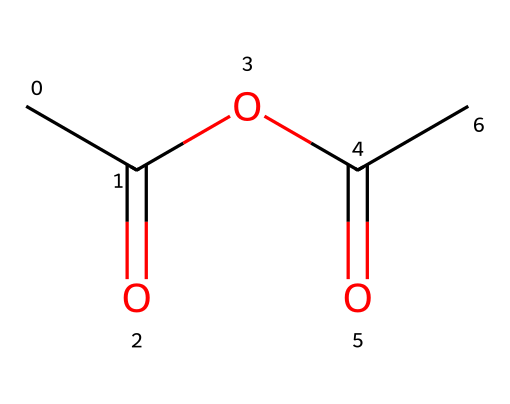How many carbon atoms are present in acetic anhydride? The SMILES representation CC(=O)OC(=O)C shows three distinct 'C' characters representing carbon atoms, hence there are three carbon atoms in acetic anhydride.
Answer: three What type of functional groups are present in this chemical structure? The acetic anhydride structure contains two carbonyl (C=O) groups and one ether (C-O) linkage, making them the primary functional groups present in the molecule.
Answer: carbonyl and ether What is the overall molecular formula of acetic anhydride? By counting the elements indicated in the SMILES, there are four hydrogen (H), six carbon (C), and two oxygen (O) atoms, leading to the molecular formula C4H6O3.
Answer: C4H6O3 Which atom is the central atom in the acetic anhydride structure? In acetic anhydride, the central focus is on the carbon atoms, as they form the backbone of the structure while linking to other functional groups, specifically the carbonyl groups.
Answer: carbon How many double bonds are present in this structure? The structure reveals two carbonyl groups (C=O), each indicating a double bond between the carbon and oxygen atoms; thus, there are two double bonds in total in acetic anhydride.
Answer: two What is the significance of the anhydride functional group in this molecule? The anhydride functional group indicates that this molecule can easily undergo hydrolysis, reacting with water to give two acetic acid molecules, which is significant in various chemical processes and applications.
Answer: hydrolysis significance Is acetic anhydride a solid, liquid, or gas at room temperature? Acetic anhydride is a liquid at room temperature, based on its properties and boiling point, which is approximately 139 degrees Celsius, indicating a liquid state under normal conditions.
Answer: liquid 